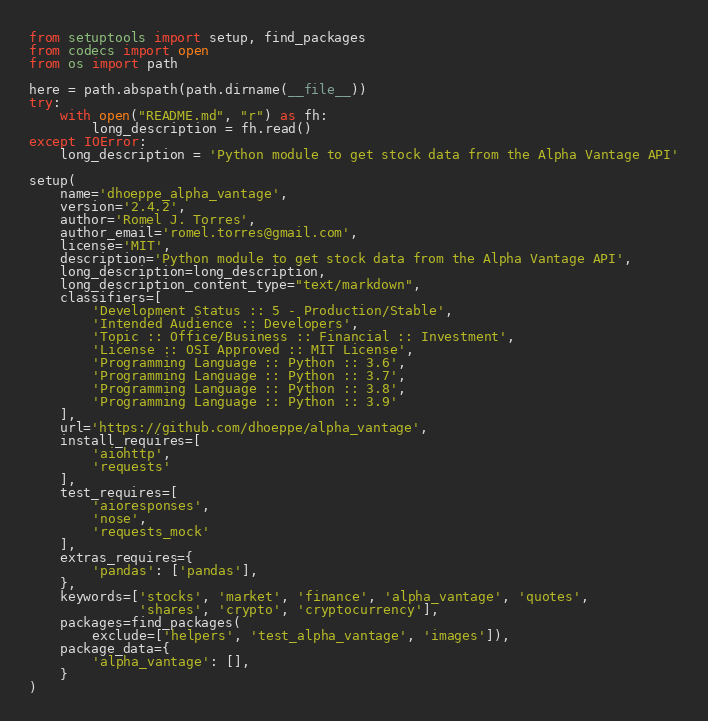<code> <loc_0><loc_0><loc_500><loc_500><_Python_>from setuptools import setup, find_packages
from codecs import open
from os import path

here = path.abspath(path.dirname(__file__))
try:
    with open("README.md", "r") as fh:
        long_description = fh.read()
except IOError:
    long_description = 'Python module to get stock data from the Alpha Vantage API'

setup(
    name='dhoeppe_alpha_vantage',
    version='2.4.2',
    author='Romel J. Torres',
    author_email='romel.torres@gmail.com',
    license='MIT',
    description='Python module to get stock data from the Alpha Vantage API',
    long_description=long_description,
    long_description_content_type="text/markdown",
    classifiers=[
        'Development Status :: 5 - Production/Stable',
        'Intended Audience :: Developers',
        'Topic :: Office/Business :: Financial :: Investment',
        'License :: OSI Approved :: MIT License',
        'Programming Language :: Python :: 3.6',
        'Programming Language :: Python :: 3.7',
        'Programming Language :: Python :: 3.8',
        'Programming Language :: Python :: 3.9'
    ],
    url='https://github.com/dhoeppe/alpha_vantage',
    install_requires=[
        'aiohttp',
        'requests'
    ],
    test_requires=[
        'aioresponses',
        'nose',
        'requests_mock'
    ],
    extras_requires={
        'pandas': ['pandas'],
    },
    keywords=['stocks', 'market', 'finance', 'alpha_vantage', 'quotes',
              'shares', 'crypto', 'cryptocurrency'],
    packages=find_packages(
        exclude=['helpers', 'test_alpha_vantage', 'images']),
    package_data={
        'alpha_vantage': [],
    }
)
</code> 